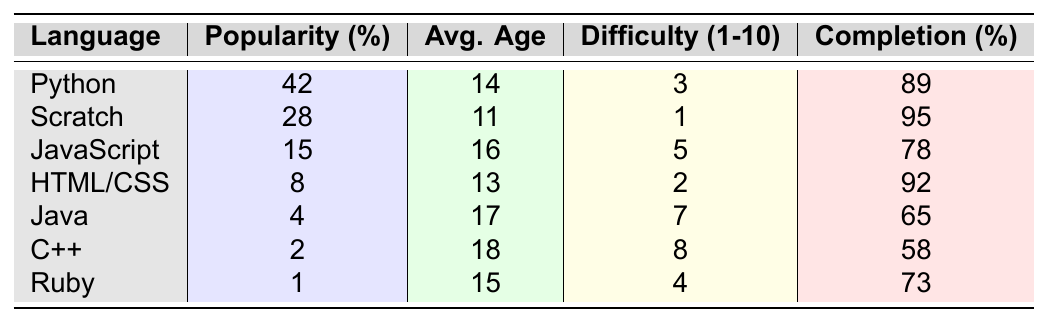What is the most popular programming language among youth coding bootcamp participants? The table shows the "Popularity (%)" values for each programming language. Python has the highest percentage at 42%, making it the most popular language among participants.
Answer: Python Which programming language has the lowest completion rate? The completion rates are listed for each language. C++ has the lowest completion rate at 58%.
Answer: C++ What is the average age of participants learning JavaScript? The table provides the "Average Age of Participants" for each language. For JavaScript, the average age is 16.
Answer: 16 Is Scratch easier to learn than Python? The difficulty levels are listed in the table, with Scratch rated at 1 and Python at 3. A lower number indicates easier difficulty, so Scratch is indeed easier than Python.
Answer: Yes What is the difference in popularity between Python and Java? The popularity of Python is 42% and Java is 4%. To find the difference, subtract Java’s popularity from Python’s: 42 - 4 = 38.
Answer: 38 Which programming language has the highest average age of participants? The "Average Age of Participants" values show that C++ has the highest average age at 18.
Answer: C++ What is the average difficulty level of the programming languages listed in the table? The difficulty levels are 3 (Python), 1 (Scratch), 5 (JavaScript), 2 (HTML/CSS), 7 (Java), 8 (C++), and 4 (Ruby). The sum is 26, and there are 7 languages, so the average difficulty is 26/7 = approximately 3.71.
Answer: 3.71 Which programming language is preferred by younger participants based on average age? The average ages indicate that Scratch has the youngest average age at 11, making it the preferred language for younger participants.
Answer: Scratch How many programming languages have a popularity of less than 10%? Looking at the "Popularity (%)" column, only Ruby (1%) and C++ (2%) have less than 10% popularity. Thus, there are 2 languages with popularity below 10%.
Answer: 2 Is it true that the project completion rate for HTML/CSS is higher than that for Java? The completion rate for HTML/CSS is 92% and for Java it is 65%. Since 92% is greater than 65%, the statement is true.
Answer: Yes 